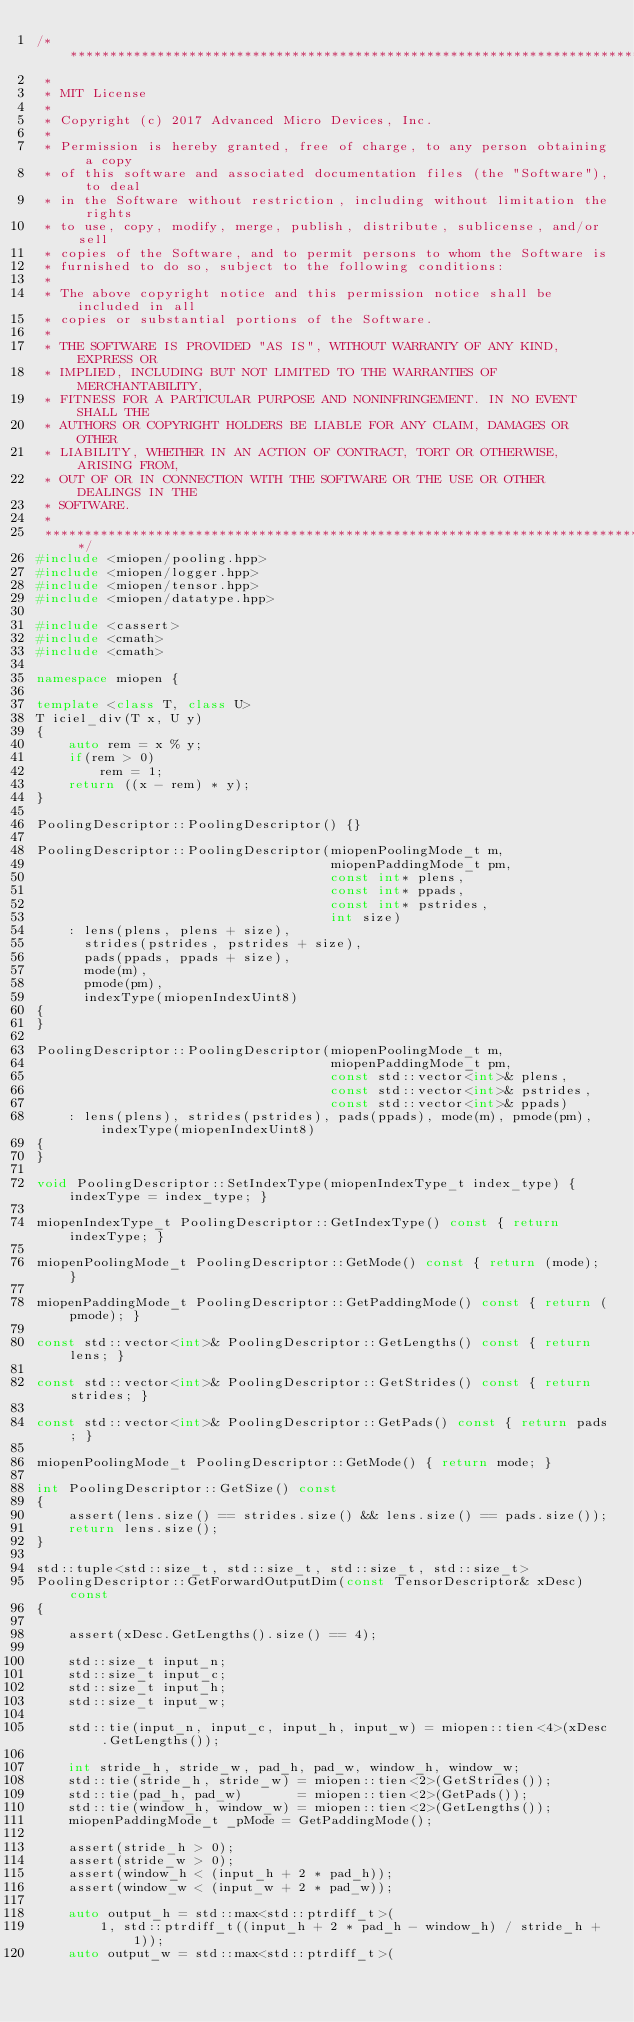<code> <loc_0><loc_0><loc_500><loc_500><_C++_>/*******************************************************************************
 *
 * MIT License
 *
 * Copyright (c) 2017 Advanced Micro Devices, Inc.
 *
 * Permission is hereby granted, free of charge, to any person obtaining a copy
 * of this software and associated documentation files (the "Software"), to deal
 * in the Software without restriction, including without limitation the rights
 * to use, copy, modify, merge, publish, distribute, sublicense, and/or sell
 * copies of the Software, and to permit persons to whom the Software is
 * furnished to do so, subject to the following conditions:
 *
 * The above copyright notice and this permission notice shall be included in all
 * copies or substantial portions of the Software.
 *
 * THE SOFTWARE IS PROVIDED "AS IS", WITHOUT WARRANTY OF ANY KIND, EXPRESS OR
 * IMPLIED, INCLUDING BUT NOT LIMITED TO THE WARRANTIES OF MERCHANTABILITY,
 * FITNESS FOR A PARTICULAR PURPOSE AND NONINFRINGEMENT. IN NO EVENT SHALL THE
 * AUTHORS OR COPYRIGHT HOLDERS BE LIABLE FOR ANY CLAIM, DAMAGES OR OTHER
 * LIABILITY, WHETHER IN AN ACTION OF CONTRACT, TORT OR OTHERWISE, ARISING FROM,
 * OUT OF OR IN CONNECTION WITH THE SOFTWARE OR THE USE OR OTHER DEALINGS IN THE
 * SOFTWARE.
 *
 *******************************************************************************/
#include <miopen/pooling.hpp>
#include <miopen/logger.hpp>
#include <miopen/tensor.hpp>
#include <miopen/datatype.hpp>

#include <cassert>
#include <cmath>
#include <cmath>

namespace miopen {

template <class T, class U>
T iciel_div(T x, U y)
{
    auto rem = x % y;
    if(rem > 0)
        rem = 1;
    return ((x - rem) * y);
}

PoolingDescriptor::PoolingDescriptor() {}

PoolingDescriptor::PoolingDescriptor(miopenPoolingMode_t m,
                                     miopenPaddingMode_t pm,
                                     const int* plens,
                                     const int* ppads,
                                     const int* pstrides,
                                     int size)
    : lens(plens, plens + size),
      strides(pstrides, pstrides + size),
      pads(ppads, ppads + size),
      mode(m),
      pmode(pm),
      indexType(miopenIndexUint8)
{
}

PoolingDescriptor::PoolingDescriptor(miopenPoolingMode_t m,
                                     miopenPaddingMode_t pm,
                                     const std::vector<int>& plens,
                                     const std::vector<int>& pstrides,
                                     const std::vector<int>& ppads)
    : lens(plens), strides(pstrides), pads(ppads), mode(m), pmode(pm), indexType(miopenIndexUint8)
{
}

void PoolingDescriptor::SetIndexType(miopenIndexType_t index_type) { indexType = index_type; }

miopenIndexType_t PoolingDescriptor::GetIndexType() const { return indexType; }

miopenPoolingMode_t PoolingDescriptor::GetMode() const { return (mode); }

miopenPaddingMode_t PoolingDescriptor::GetPaddingMode() const { return (pmode); }

const std::vector<int>& PoolingDescriptor::GetLengths() const { return lens; }

const std::vector<int>& PoolingDescriptor::GetStrides() const { return strides; }

const std::vector<int>& PoolingDescriptor::GetPads() const { return pads; }

miopenPoolingMode_t PoolingDescriptor::GetMode() { return mode; }

int PoolingDescriptor::GetSize() const
{
    assert(lens.size() == strides.size() && lens.size() == pads.size());
    return lens.size();
}

std::tuple<std::size_t, std::size_t, std::size_t, std::size_t>
PoolingDescriptor::GetForwardOutputDim(const TensorDescriptor& xDesc) const
{

    assert(xDesc.GetLengths().size() == 4);

    std::size_t input_n;
    std::size_t input_c;
    std::size_t input_h;
    std::size_t input_w;

    std::tie(input_n, input_c, input_h, input_w) = miopen::tien<4>(xDesc.GetLengths());

    int stride_h, stride_w, pad_h, pad_w, window_h, window_w;
    std::tie(stride_h, stride_w) = miopen::tien<2>(GetStrides());
    std::tie(pad_h, pad_w)       = miopen::tien<2>(GetPads());
    std::tie(window_h, window_w) = miopen::tien<2>(GetLengths());
    miopenPaddingMode_t _pMode = GetPaddingMode();

    assert(stride_h > 0);
    assert(stride_w > 0);
    assert(window_h < (input_h + 2 * pad_h));
    assert(window_w < (input_w + 2 * pad_w));

    auto output_h = std::max<std::ptrdiff_t>(
        1, std::ptrdiff_t((input_h + 2 * pad_h - window_h) / stride_h + 1));
    auto output_w = std::max<std::ptrdiff_t>(</code> 